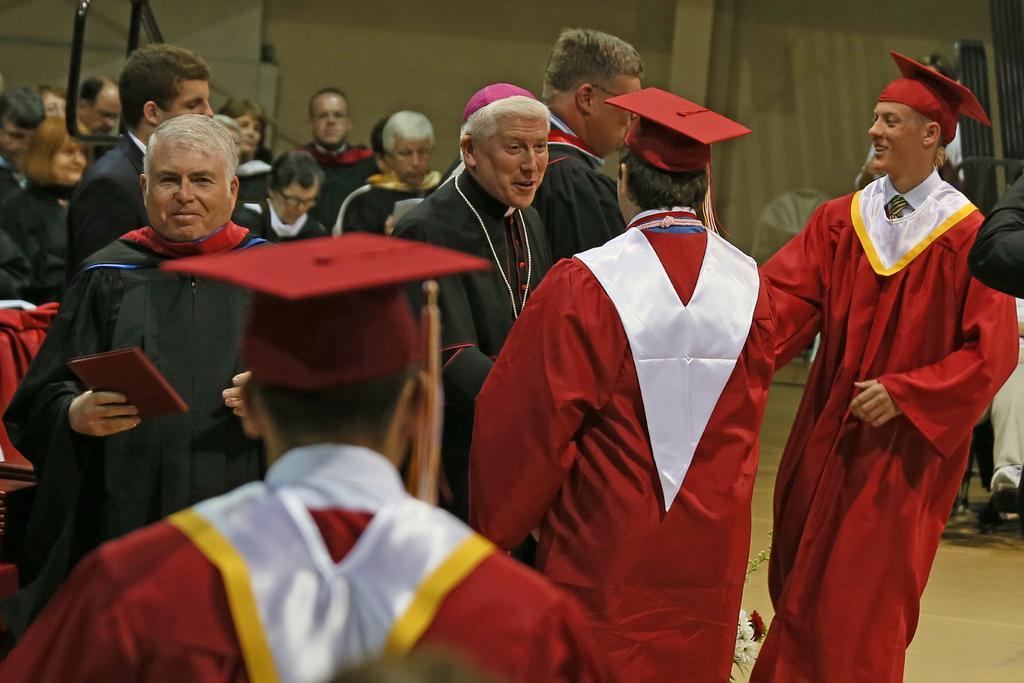Can you describe this image briefly? In this image we can see some people and among them few people are wearing Academic dresses and we can see some objects and the wall in the background. 